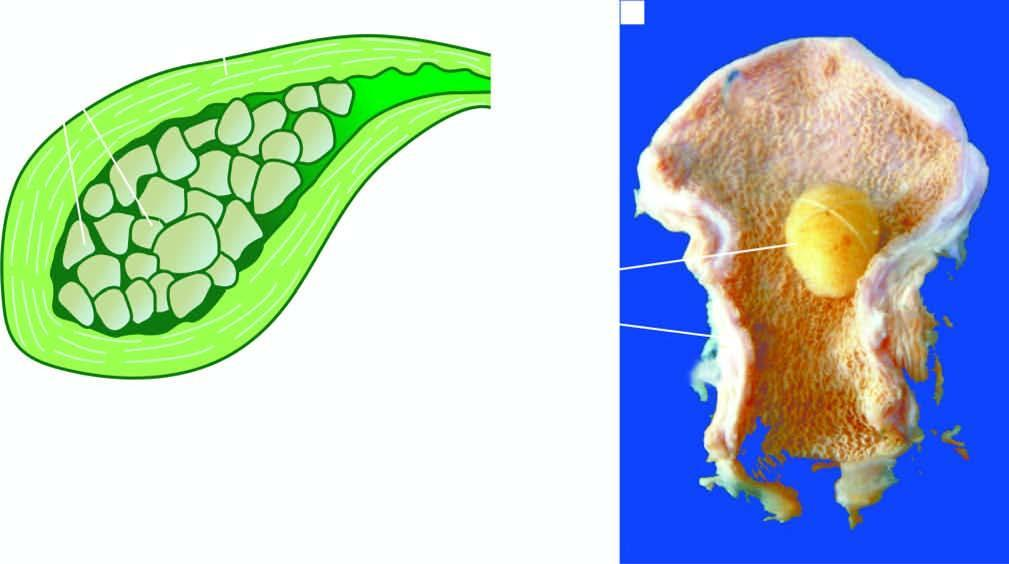what contains a single, large, oval, and hard yellow-white gallstone?
Answer the question using a single word or phrase. Lumen 